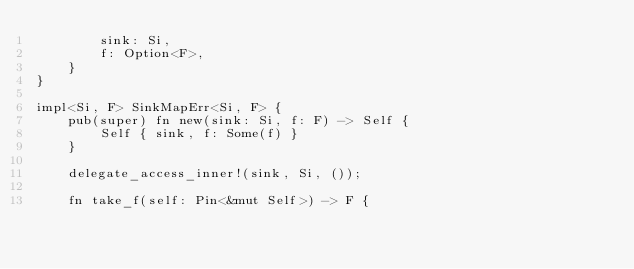Convert code to text. <code><loc_0><loc_0><loc_500><loc_500><_Rust_>        sink: Si,
        f: Option<F>,
    }
}

impl<Si, F> SinkMapErr<Si, F> {
    pub(super) fn new(sink: Si, f: F) -> Self {
        Self { sink, f: Some(f) }
    }

    delegate_access_inner!(sink, Si, ());

    fn take_f(self: Pin<&mut Self>) -> F {</code> 